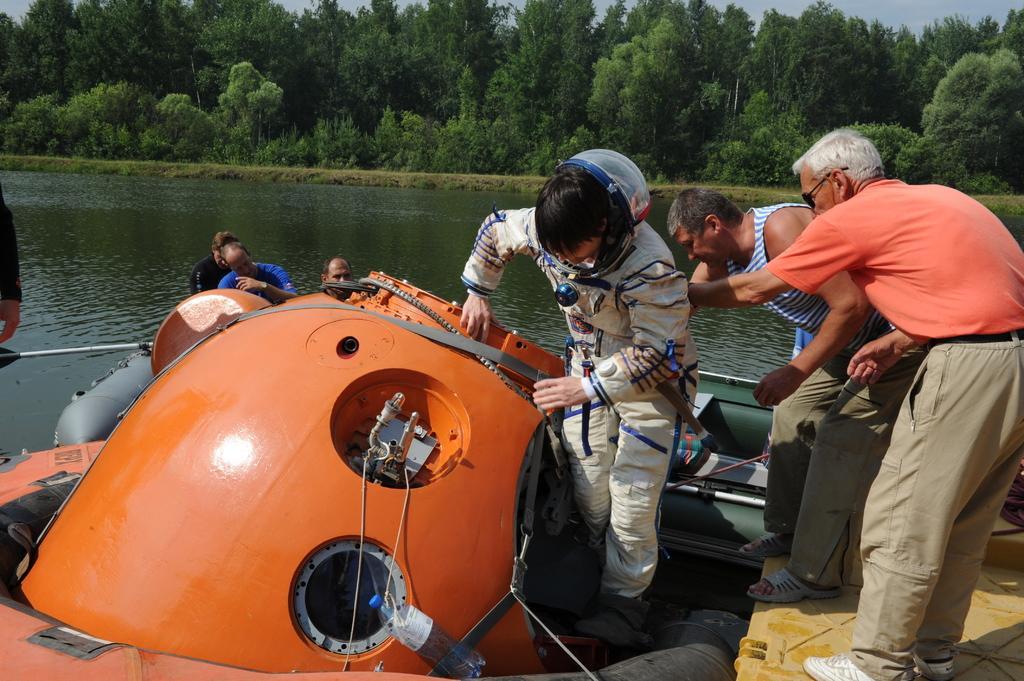How would you summarize this image in a sentence or two? In this picture i can see people are standing on the boat. In the background i can see water, trees and sky. The person in the middle is wearing a white color suit. 